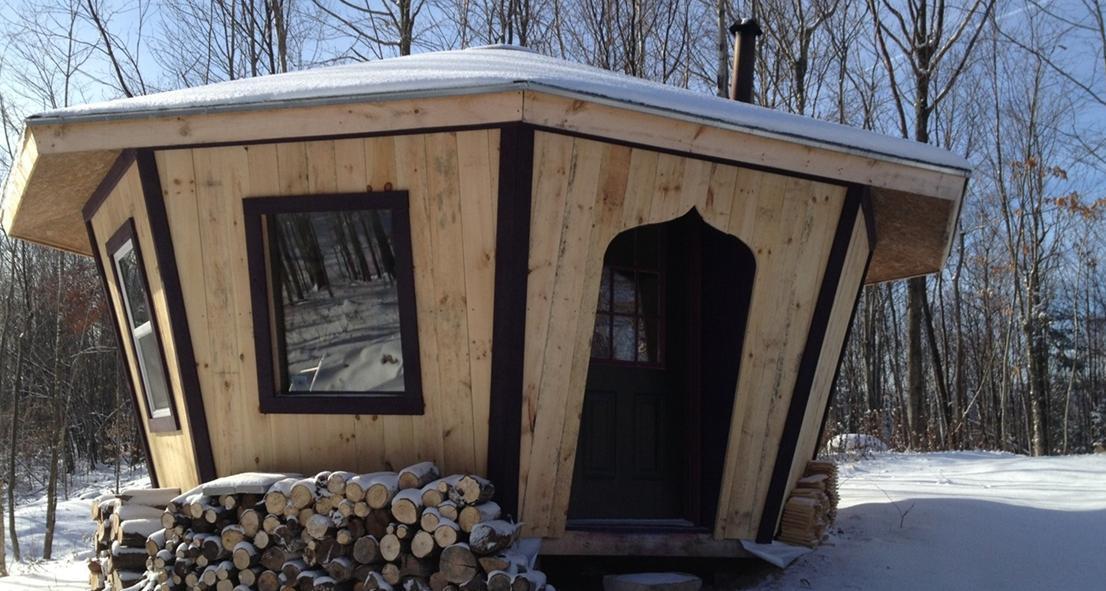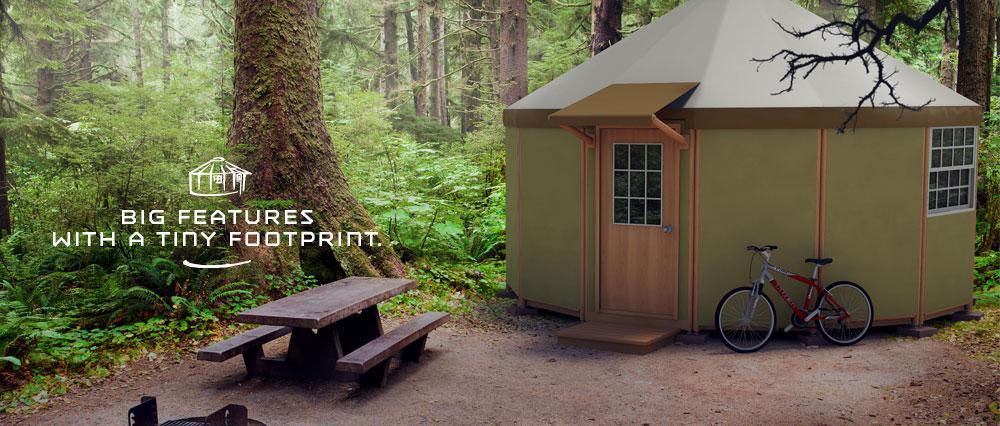The first image is the image on the left, the second image is the image on the right. Examine the images to the left and right. Is the description "One image shows a cylindrical olive-green building with one door." accurate? Answer yes or no. Yes. 